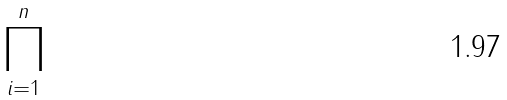<formula> <loc_0><loc_0><loc_500><loc_500>\prod _ { i = 1 } ^ { n }</formula> 